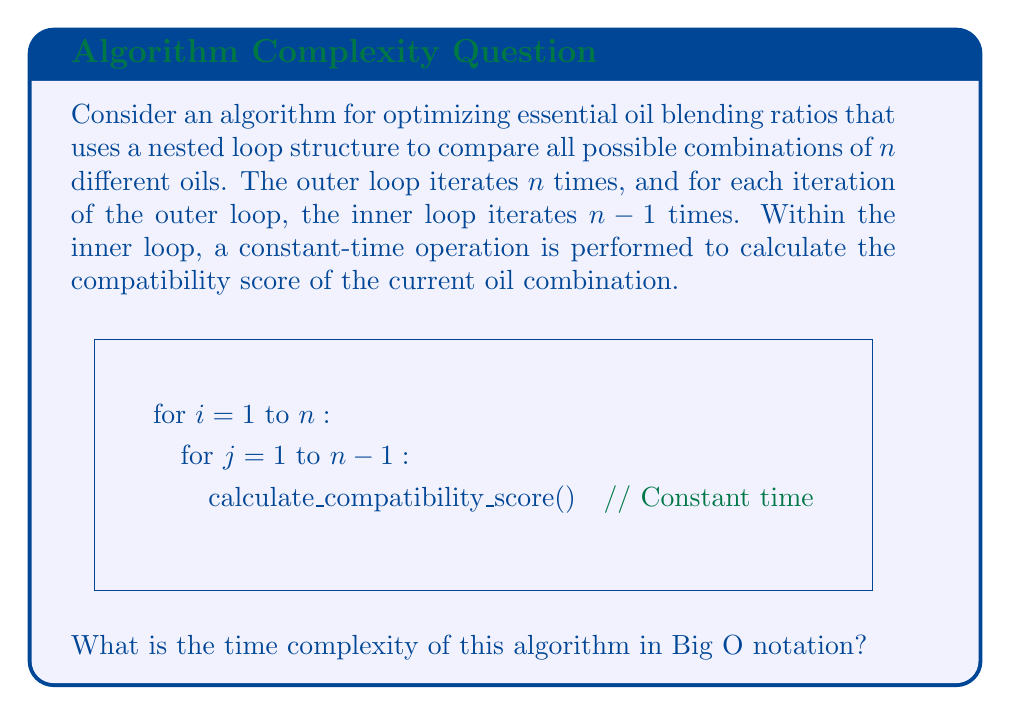Solve this math problem. Let's analyze the algorithm step by step:

1) The outer loop iterates n times.

2) For each iteration of the outer loop, the inner loop iterates n-1 times.

3) This creates a nested loop structure where the total number of iterations is:

   $$n * (n-1) = n^2 - n$$

4) Inside the innermost loop, a constant-time operation is performed. Let's call the time for this operation c.

5) So, the total time T(n) can be expressed as:

   $$T(n) = c(n^2 - n)$$

6) In Big O notation, we're interested in the asymptotic behavior as n grows large. We can simplify this by:
   
   a) Dropping lower-order terms: $n^2$ grows much faster than $n$, so $n^2 - n \approx n^2$ for large n.
   
   b) Dropping constant factors: The $c$ doesn't affect the rate of growth.

7) Therefore, the time complexity simplifies to $O(n^2)$.

This quadratic time complexity indicates that the algorithm's running time grows quadratically with the number of essential oils being considered, which could become inefficient for large numbers of oils.
Answer: $O(n^2)$ 